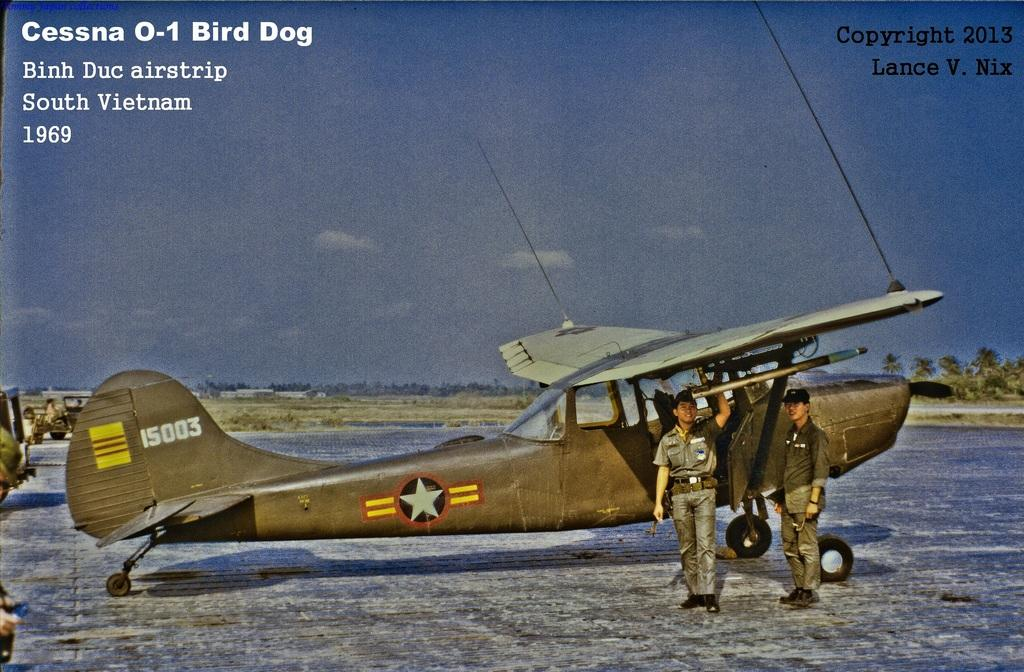<image>
Share a concise interpretation of the image provided. A postcard with the Cessna 0-1 Bird Dog on the front. 